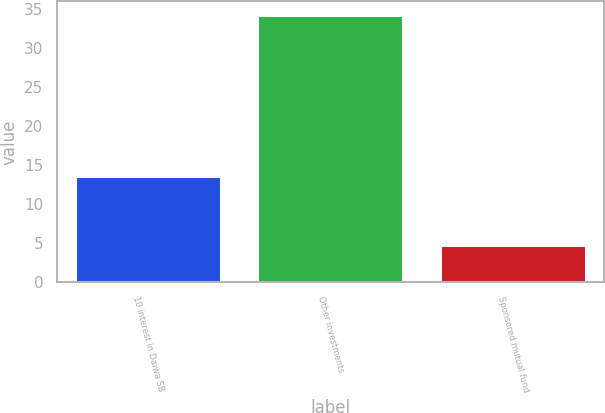Convert chart. <chart><loc_0><loc_0><loc_500><loc_500><bar_chart><fcel>10 interest in Daiwa SB<fcel>Other investments<fcel>Sponsored mutual fund<nl><fcel>13.6<fcel>34.2<fcel>4.8<nl></chart> 